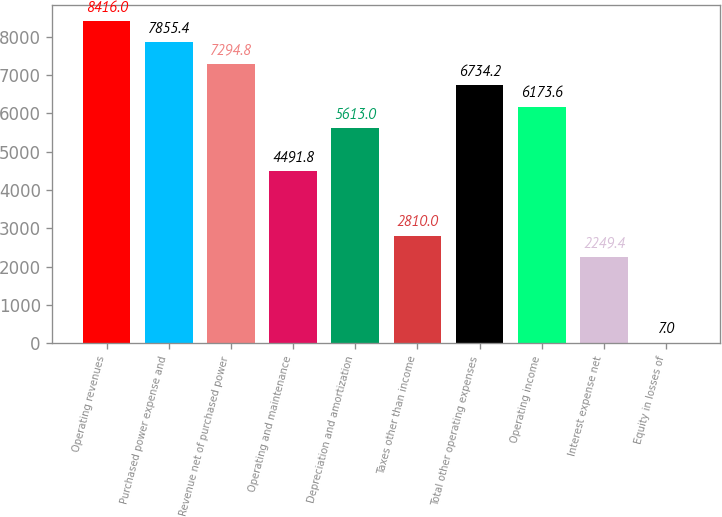Convert chart. <chart><loc_0><loc_0><loc_500><loc_500><bar_chart><fcel>Operating revenues<fcel>Purchased power expense and<fcel>Revenue net of purchased power<fcel>Operating and maintenance<fcel>Depreciation and amortization<fcel>Taxes other than income<fcel>Total other operating expenses<fcel>Operating income<fcel>Interest expense net<fcel>Equity in losses of<nl><fcel>8416<fcel>7855.4<fcel>7294.8<fcel>4491.8<fcel>5613<fcel>2810<fcel>6734.2<fcel>6173.6<fcel>2249.4<fcel>7<nl></chart> 